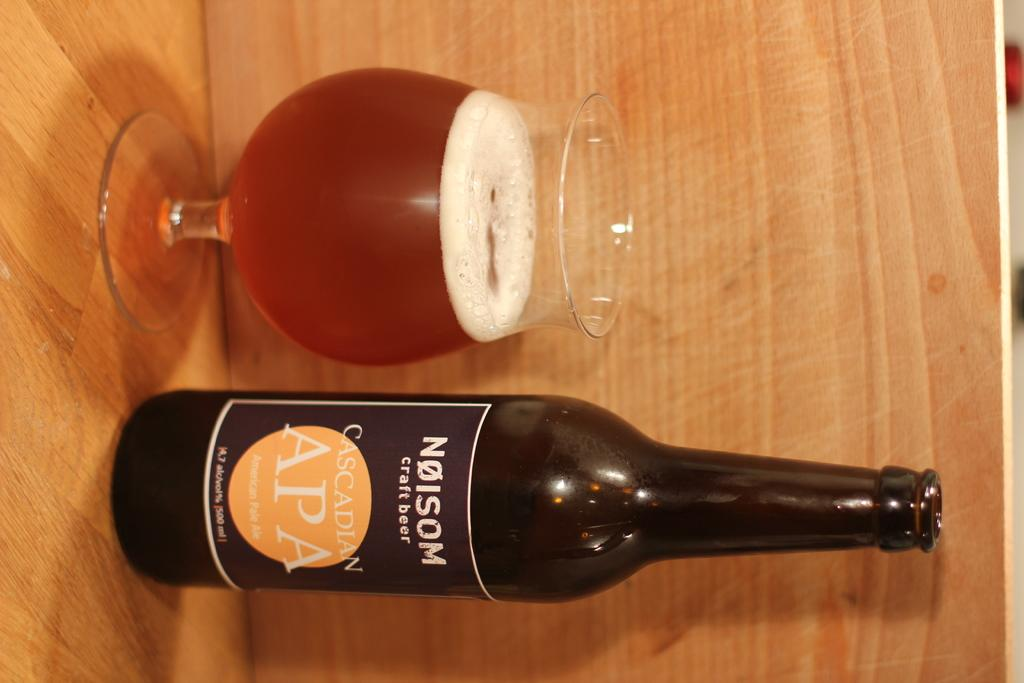<image>
Offer a succinct explanation of the picture presented. a bottle of beer with the word Nolsom on it next to a glass of same. 